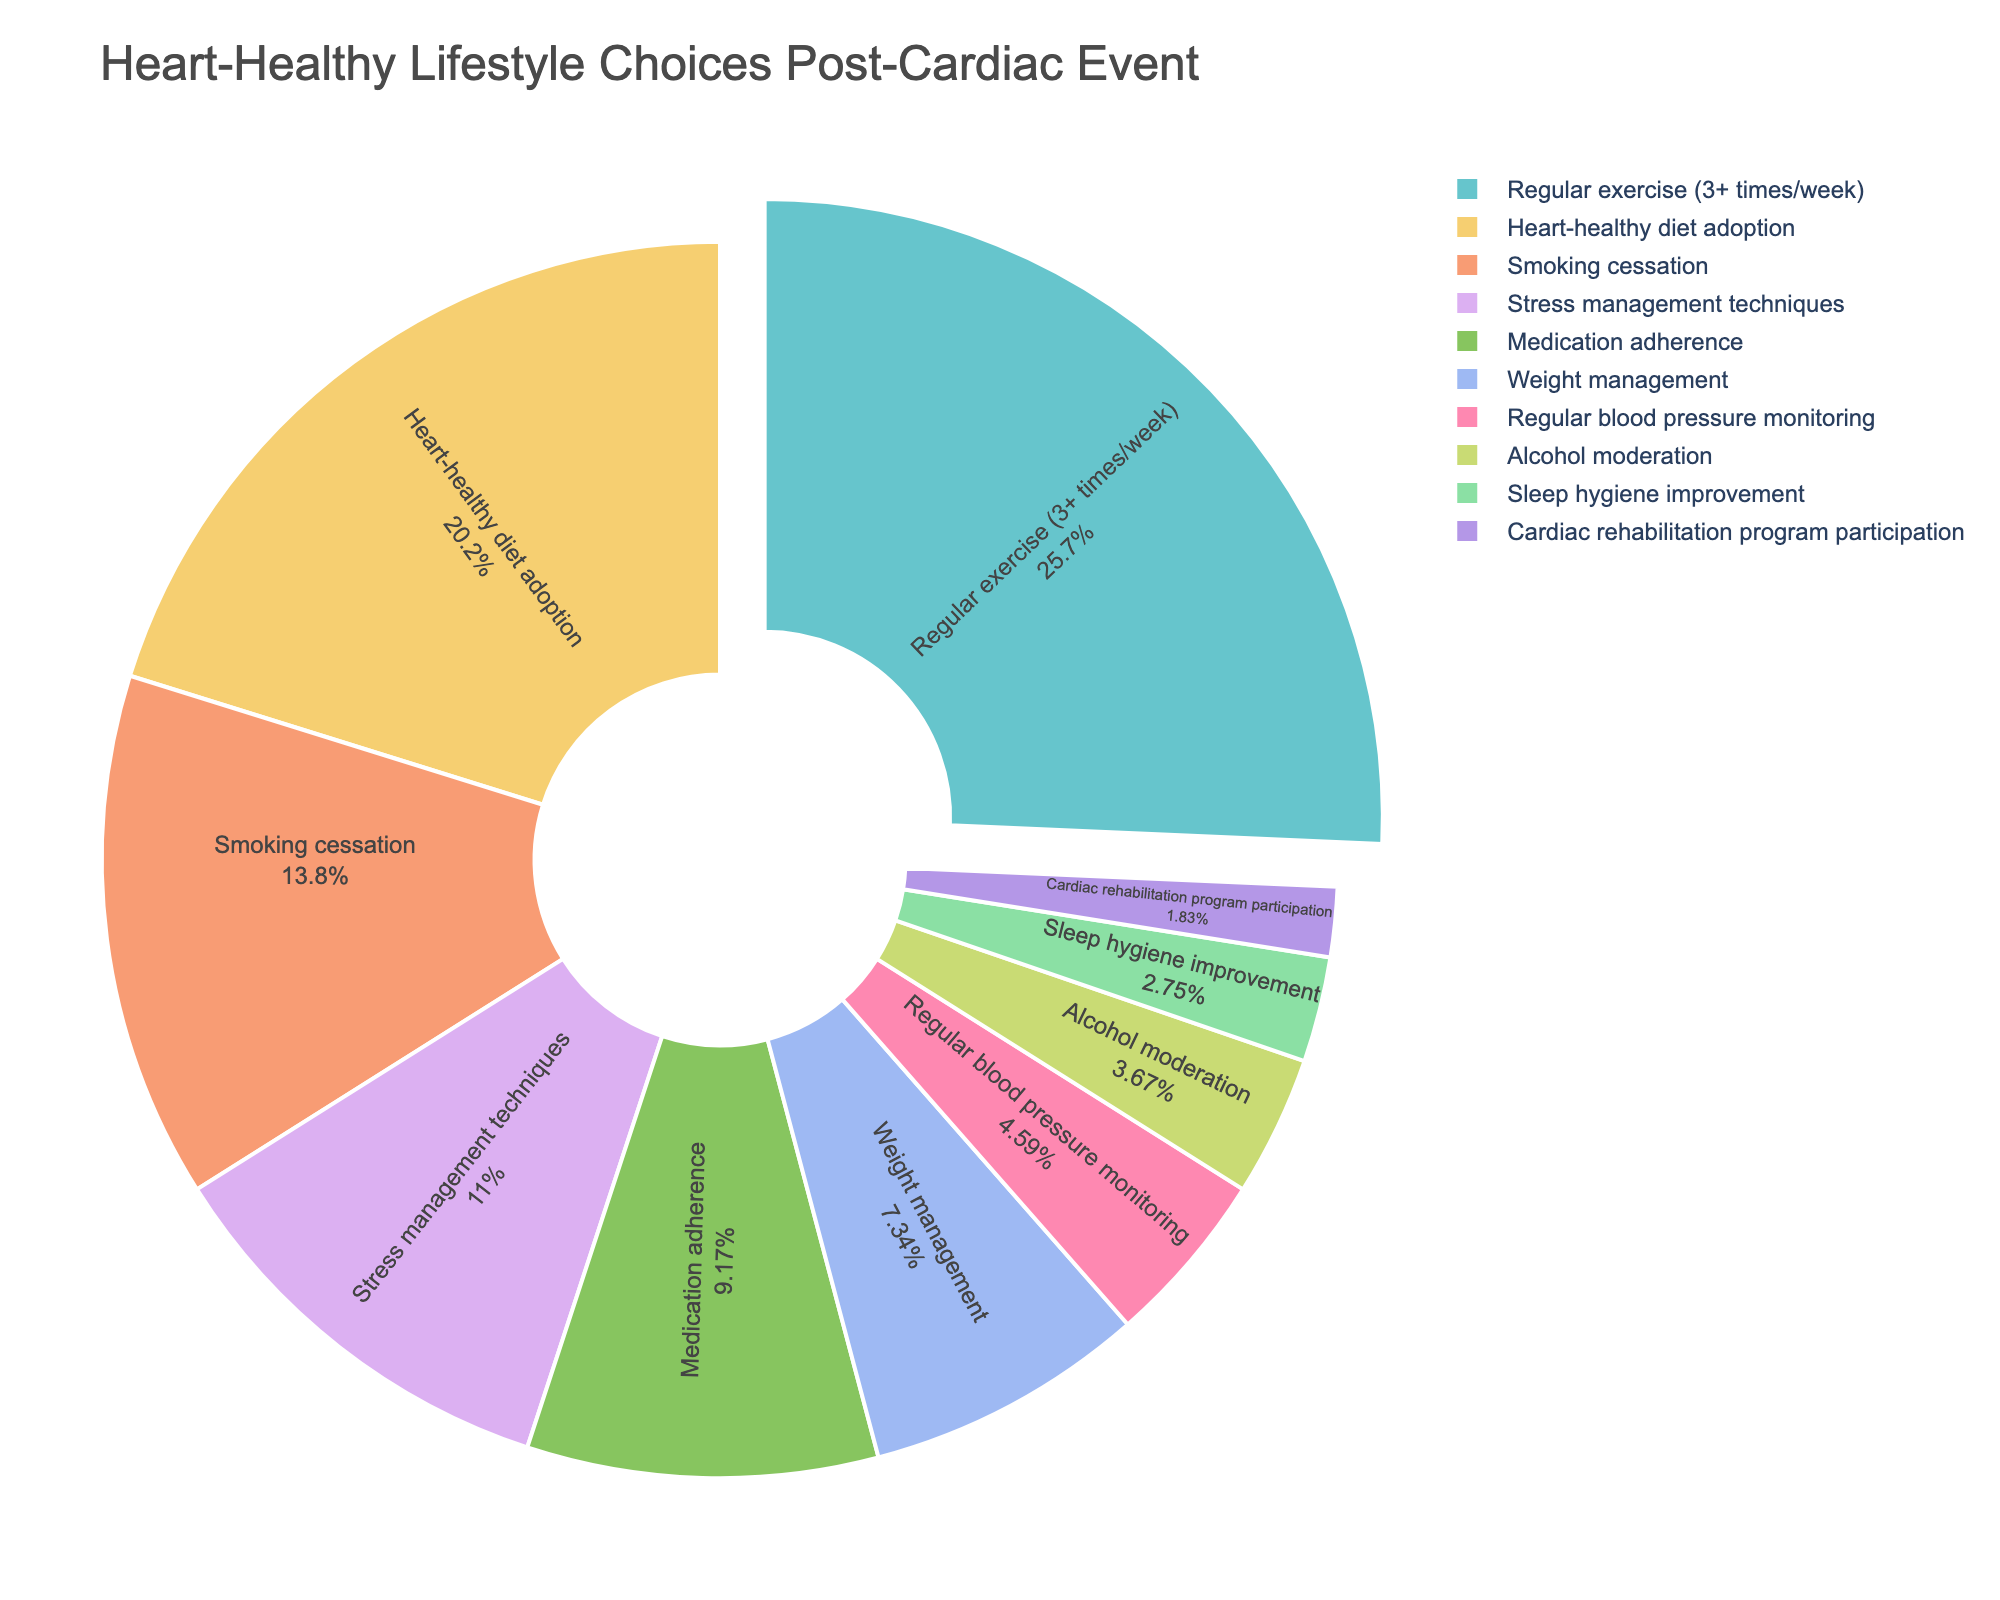What's the main lifestyle choice adopted by patients? The largest segment of the pie chart represents the primary lifestyle choice, which is "Regular exercise (3+ times/week)" at 28%.
Answer: Regular exercise (3+ times/week) What percentage of patients adopted a heart-healthy diet? By looking at the pie chart, the segment labeled "Heart-healthy diet adoption" shows its percentage. It is 22%.
Answer: 22% Which lifestyle choice has the least adoption by patients? The smallest segment in the pie chart indicates the least adopted choice, which is "Cardiac rehabilitation program participation" at 2%.
Answer: Cardiac rehabilitation program participation Are more patients focused on smoking cessation or medication adherence? Comparing the segments for smoking cessation (15%) and medication adherence (10%) reveals that more patients are focused on smoking cessation.
Answer: Smoking cessation How much higher is the adoption of stress management techniques compared to regular blood pressure monitoring? The percentage of stress management techniques is 12%, while regular blood pressure monitoring is 5%. The difference is 12% - 5% = 7%.
Answer: 7% What is the combined percentage of patients adopting either weight management or sleep hygiene improvement? Weight management accounts for 8%, and sleep hygiene improvement accounts for 3%. The combined percentage is 8% + 3% = 11%.
Answer: 11% Which lifestyle choices constitute at least 10% of the total adoption? Identifying segments with percentages 10% or higher include "Regular exercise (3+ times/week)" at 28%, "Heart-healthy diet adoption" at 22%, "Smoking cessation" at 15%, and "Stress management techniques" at 12%.
Answer: Regular exercise (3+ times/week), Heart-healthy diet adoption, Smoking cessation, Stress management techniques By what factor is the adoption of alcohol moderation less than regular exercise? Regular exercise adoption is 28%, and alcohol moderation is 4%. The factor is 28% / 4% = 7.
Answer: 7 What percent of patients adopted lifestyle choices related to diet and weight combined? Adding the percentages of "Heart-healthy diet adoption" (22%) and "Weight management" (8%) gives a combined adoption of 22% + 8% = 30%.
Answer: 30% Which is more common: stress management or sleep hygiene improvement, and by what percent? Stress management techniques are at 12%, while sleep hygiene improvement is at 3%. The difference is 12% - 3% = 9%.
Answer: Stress management, 9% 